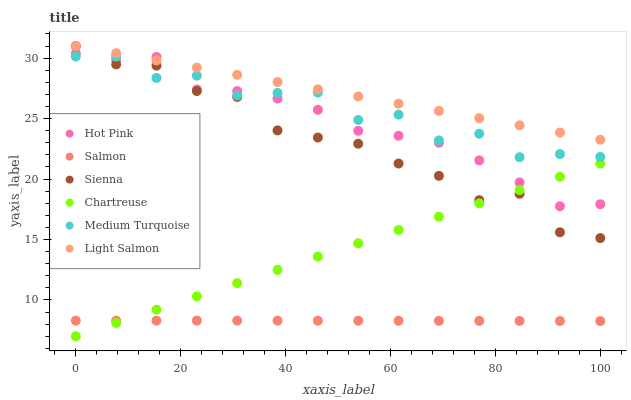Does Salmon have the minimum area under the curve?
Answer yes or no. Yes. Does Light Salmon have the maximum area under the curve?
Answer yes or no. Yes. Does Hot Pink have the minimum area under the curve?
Answer yes or no. No. Does Hot Pink have the maximum area under the curve?
Answer yes or no. No. Is Light Salmon the smoothest?
Answer yes or no. Yes. Is Medium Turquoise the roughest?
Answer yes or no. Yes. Is Hot Pink the smoothest?
Answer yes or no. No. Is Hot Pink the roughest?
Answer yes or no. No. Does Chartreuse have the lowest value?
Answer yes or no. Yes. Does Hot Pink have the lowest value?
Answer yes or no. No. Does Sienna have the highest value?
Answer yes or no. Yes. Does Hot Pink have the highest value?
Answer yes or no. No. Is Salmon less than Hot Pink?
Answer yes or no. Yes. Is Medium Turquoise greater than Chartreuse?
Answer yes or no. Yes. Does Sienna intersect Chartreuse?
Answer yes or no. Yes. Is Sienna less than Chartreuse?
Answer yes or no. No. Is Sienna greater than Chartreuse?
Answer yes or no. No. Does Salmon intersect Hot Pink?
Answer yes or no. No. 